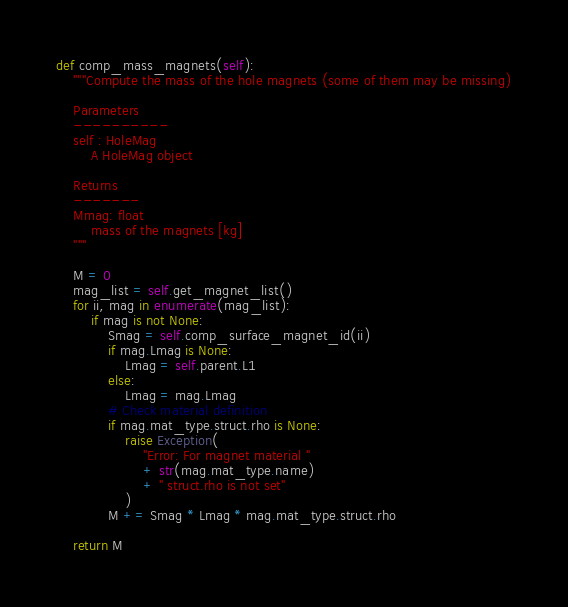<code> <loc_0><loc_0><loc_500><loc_500><_Python_>def comp_mass_magnets(self):
    """Compute the mass of the hole magnets (some of them may be missing)

    Parameters
    ----------
    self : HoleMag
        A HoleMag object

    Returns
    -------
    Mmag: float
        mass of the magnets [kg]
    """

    M = 0
    mag_list = self.get_magnet_list()
    for ii, mag in enumerate(mag_list):
        if mag is not None:
            Smag = self.comp_surface_magnet_id(ii)
            if mag.Lmag is None:
                Lmag = self.parent.L1
            else:
                Lmag = mag.Lmag
            # Check material definition
            if mag.mat_type.struct.rho is None:
                raise Exception(
                    "Error: For magnet material "
                    + str(mag.mat_type.name)
                    + " struct.rho is not set"
                )
            M += Smag * Lmag * mag.mat_type.struct.rho

    return M
</code> 